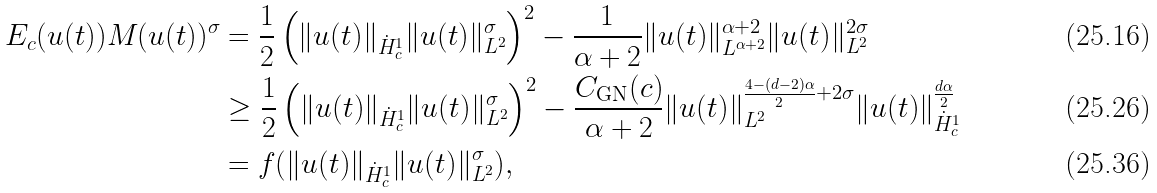Convert formula to latex. <formula><loc_0><loc_0><loc_500><loc_500>E _ { c } ( u ( t ) ) M ( u ( t ) ) ^ { \sigma } & = \frac { 1 } { 2 } \left ( \| u ( t ) \| _ { \dot { H } ^ { 1 } _ { c } } \| u ( t ) \| ^ { \sigma } _ { L ^ { 2 } } \right ) ^ { 2 } - \frac { 1 } { \alpha + 2 } \| u ( t ) \| ^ { \alpha + 2 } _ { L ^ { \alpha + 2 } } \| u ( t ) \| ^ { 2 \sigma } _ { L ^ { 2 } } \\ & \geq \frac { 1 } { 2 } \left ( \| u ( t ) \| _ { \dot { H } ^ { 1 } _ { c } } \| u ( t ) \| ^ { \sigma } _ { L ^ { 2 } } \right ) ^ { 2 } - \frac { C _ { \text {GN} } ( c ) } { \alpha + 2 } \| u ( t ) \| ^ { \frac { 4 - ( d - 2 ) \alpha } { 2 } + 2 \sigma } _ { L ^ { 2 } } \| u ( t ) \| ^ { \frac { d \alpha } { 2 } } _ { \dot { H } ^ { 1 } _ { c } } \\ & = f ( \| u ( t ) \| _ { \dot { H } ^ { 1 } _ { c } } \| u ( t ) \| ^ { \sigma } _ { L ^ { 2 } } ) ,</formula> 